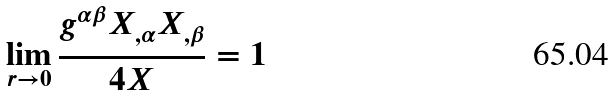Convert formula to latex. <formula><loc_0><loc_0><loc_500><loc_500>\lim _ { r \to 0 } \frac { g ^ { \alpha \beta } X _ { , \alpha } X _ { , \beta } } { 4 X } = 1</formula> 